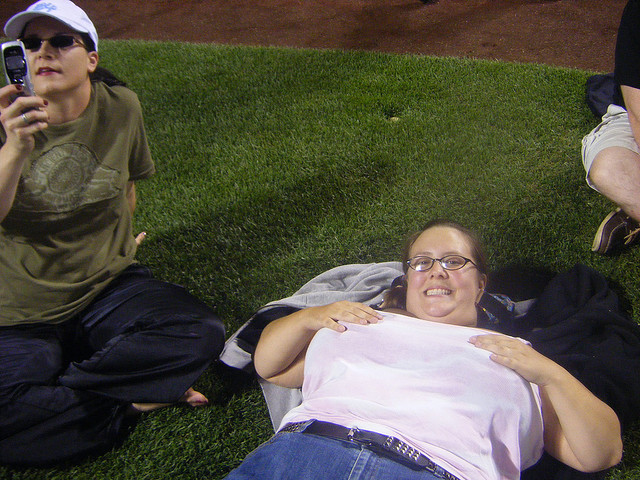<image>Does this woman laying on the ground have unaided 20/20 vision? I can't determine if the woman has unaided 20/20 vision. Does this woman laying on the ground have unaided 20/20 vision? I don't know if the woman laying on the ground has unaided 20/20 vision. It can be both yes or no. 